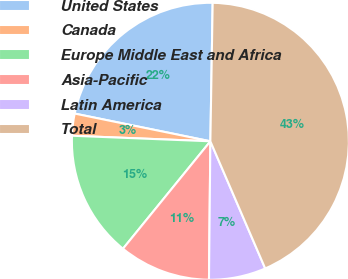<chart> <loc_0><loc_0><loc_500><loc_500><pie_chart><fcel>United States<fcel>Canada<fcel>Europe Middle East and Africa<fcel>Asia-Pacific<fcel>Latin America<fcel>Total<nl><fcel>22.06%<fcel>2.57%<fcel>14.77%<fcel>10.71%<fcel>6.64%<fcel>43.26%<nl></chart> 